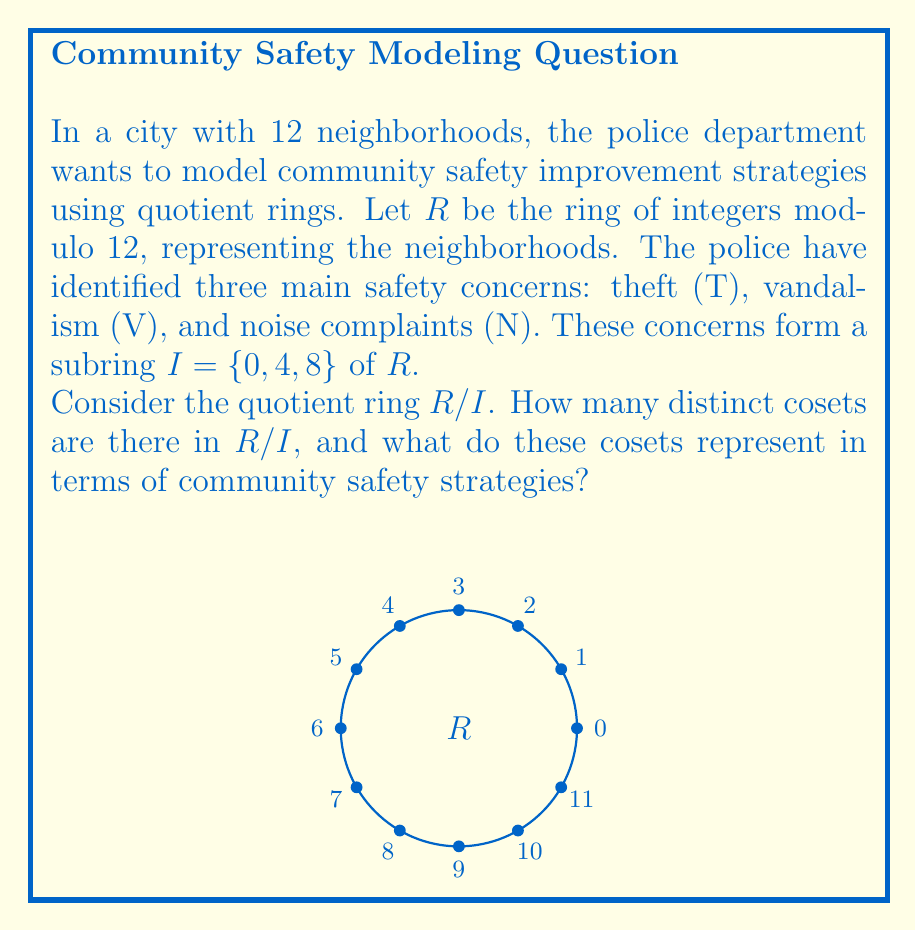Solve this math problem. Let's approach this step-by-step:

1) First, recall that in a quotient ring $R/I$, the cosets are of the form $r + I$ where $r \in R$.

2) In this case, $R = \mathbb{Z}_{12}$ and $I = \{0, 4, 8\}$.

3) To find the distinct cosets, we need to add each element of $I$ to each element of $R$ and see which results are equivalent:

   $0 + I = \{0, 4, 8\}$
   $1 + I = \{1, 5, 9\}$
   $2 + I = \{2, 6, 10\}$
   $3 + I = \{3, 7, 11\}$

4) We can see that these four cosets are distinct and cover all elements of $R$. Any other coset would be equivalent to one of these.

5) Therefore, there are 4 distinct cosets in $R/I$.

6) In terms of community safety strategies, each coset represents a group of neighborhoods that can be targeted with similar strategies:

   - $\{0, 4, 8\}$: Neighborhoods with high priority for all three concerns (T, V, N)
   - $\{1, 5, 9\}$: Neighborhoods needing strategies shifted slightly from the high-priority group
   - $\{2, 6, 10\}$: Neighborhoods requiring a different set of strategies
   - $\{3, 7, 11\}$: Neighborhoods needing strategies most different from the high-priority group

This grouping allows the police to efficiently allocate resources and tailor strategies to each group of neighborhoods.
Answer: 4 cosets, representing groups of neighborhoods for targeted safety strategies 